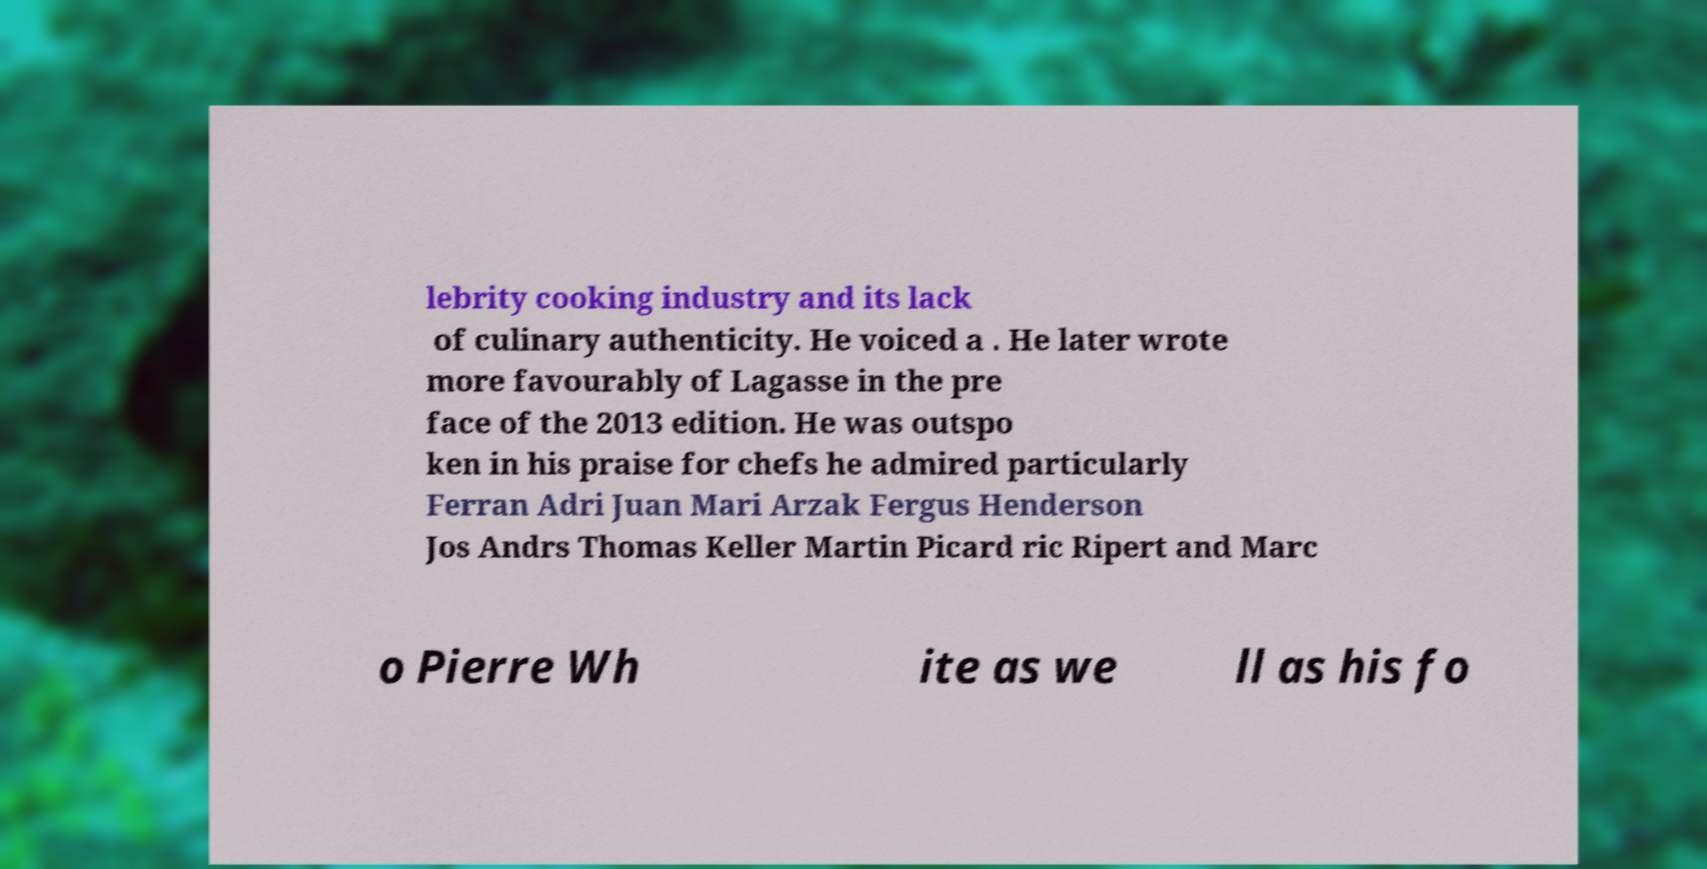Could you extract and type out the text from this image? lebrity cooking industry and its lack of culinary authenticity. He voiced a . He later wrote more favourably of Lagasse in the pre face of the 2013 edition. He was outspo ken in his praise for chefs he admired particularly Ferran Adri Juan Mari Arzak Fergus Henderson Jos Andrs Thomas Keller Martin Picard ric Ripert and Marc o Pierre Wh ite as we ll as his fo 